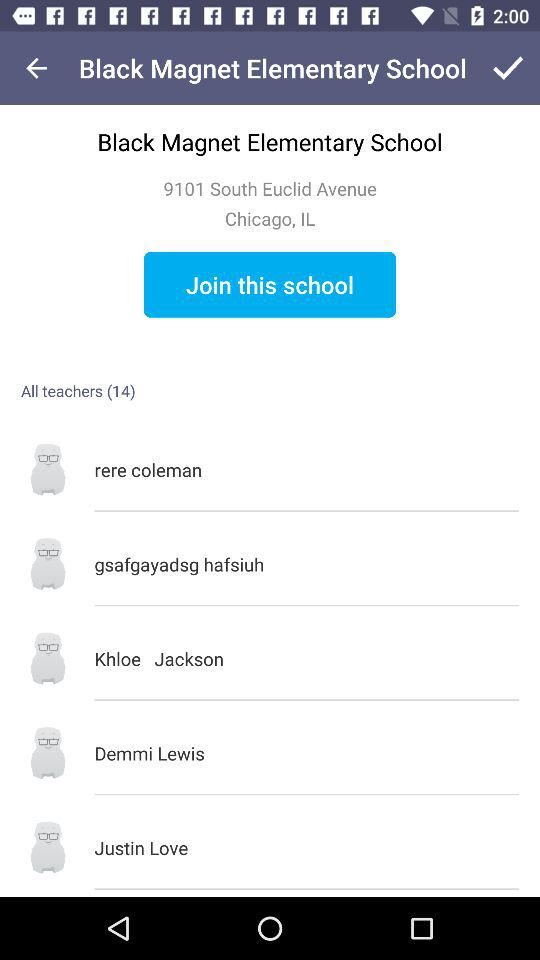What is the name of the school? The name of the school is Black Magnet Elementary School. 